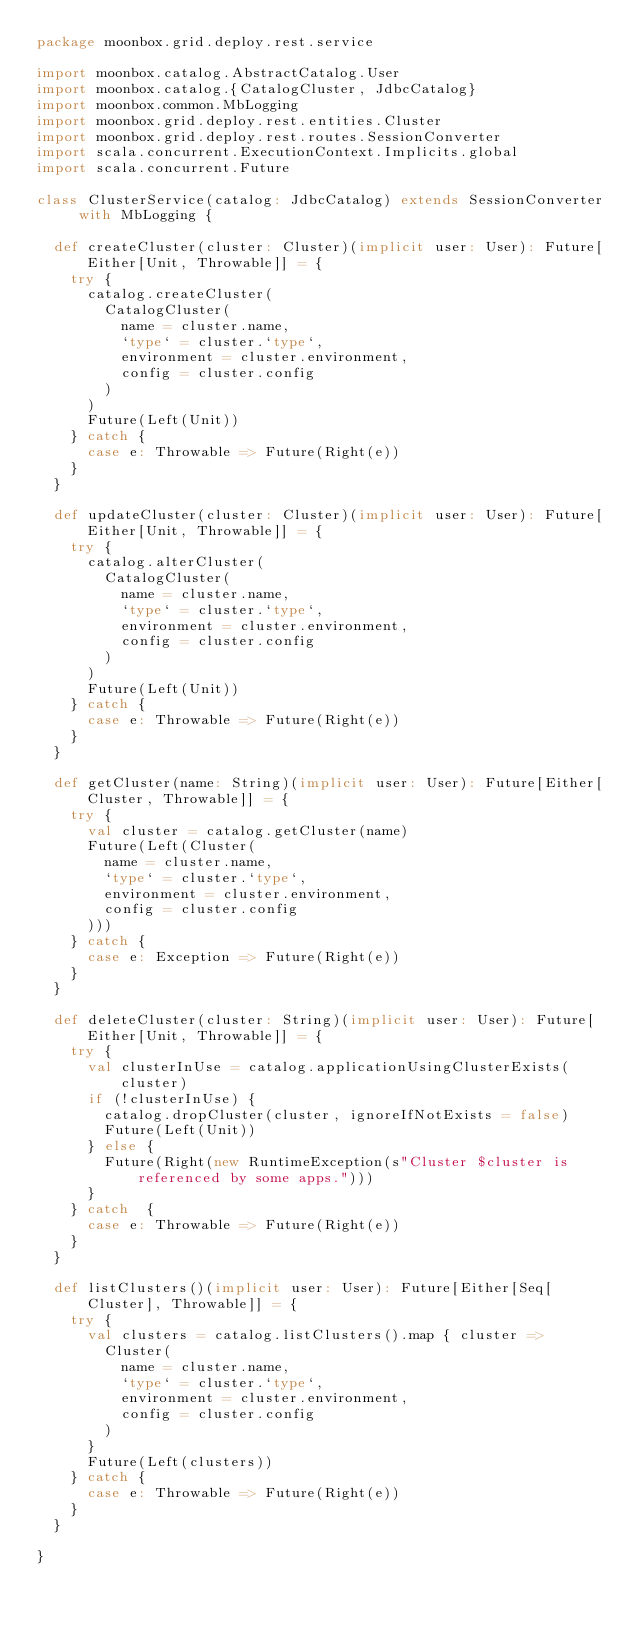Convert code to text. <code><loc_0><loc_0><loc_500><loc_500><_Scala_>package moonbox.grid.deploy.rest.service

import moonbox.catalog.AbstractCatalog.User
import moonbox.catalog.{CatalogCluster, JdbcCatalog}
import moonbox.common.MbLogging
import moonbox.grid.deploy.rest.entities.Cluster
import moonbox.grid.deploy.rest.routes.SessionConverter
import scala.concurrent.ExecutionContext.Implicits.global
import scala.concurrent.Future

class ClusterService(catalog: JdbcCatalog) extends SessionConverter with MbLogging {

	def createCluster(cluster: Cluster)(implicit user: User): Future[Either[Unit, Throwable]] = {
		try {
			catalog.createCluster(
				CatalogCluster(
					name = cluster.name,
					`type` = cluster.`type`,
					environment = cluster.environment,
					config = cluster.config
				)
			)
			Future(Left(Unit))
		} catch {
			case e: Throwable => Future(Right(e))
		}
	}

	def updateCluster(cluster: Cluster)(implicit user: User): Future[Either[Unit, Throwable]] = {
		try {
			catalog.alterCluster(
				CatalogCluster(
					name = cluster.name,
					`type` = cluster.`type`,
					environment = cluster.environment,
					config = cluster.config
				)
			)
			Future(Left(Unit))
		} catch {
			case e: Throwable => Future(Right(e))
		}
	}

	def getCluster(name: String)(implicit user: User): Future[Either[Cluster, Throwable]] = {
		try {
			val cluster = catalog.getCluster(name)
			Future(Left(Cluster(
				name = cluster.name,
				`type` = cluster.`type`,
				environment = cluster.environment,
				config = cluster.config
			)))
		} catch {
			case e: Exception => Future(Right(e))
		}
	}

	def deleteCluster(cluster: String)(implicit user: User): Future[Either[Unit, Throwable]] = {
		try {
			val clusterInUse = catalog.applicationUsingClusterExists(cluster)
			if (!clusterInUse) {
				catalog.dropCluster(cluster, ignoreIfNotExists = false)
				Future(Left(Unit))
			} else {
				Future(Right(new RuntimeException(s"Cluster $cluster is referenced by some apps.")))
			}
		} catch  {
			case e: Throwable => Future(Right(e))
		}
	}

	def listClusters()(implicit user: User): Future[Either[Seq[Cluster], Throwable]] = {
		try {
			val clusters = catalog.listClusters().map { cluster =>
				Cluster(
					name = cluster.name,
					`type` = cluster.`type`,
					environment = cluster.environment,
					config = cluster.config
				)
			}
			Future(Left(clusters))
		} catch {
			case e: Throwable => Future(Right(e))
		}
	}

}
</code> 